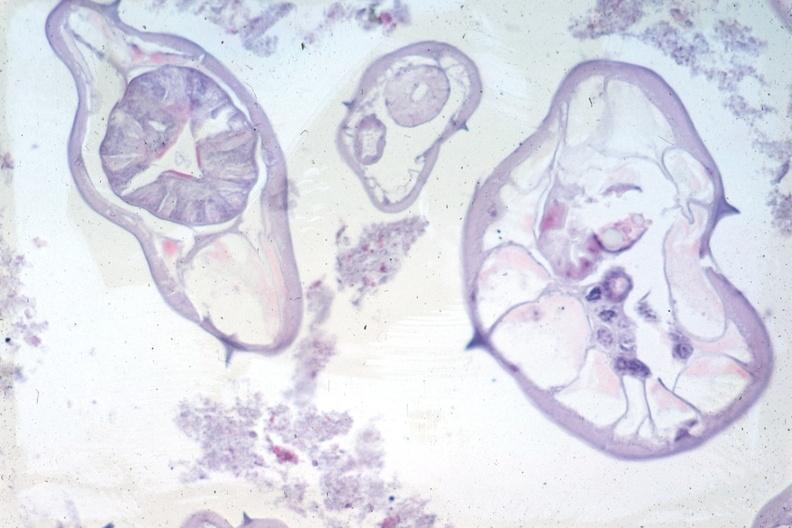what does this image show?
Answer the question using a single word or phrase. Organisms not appendix structures in photo 